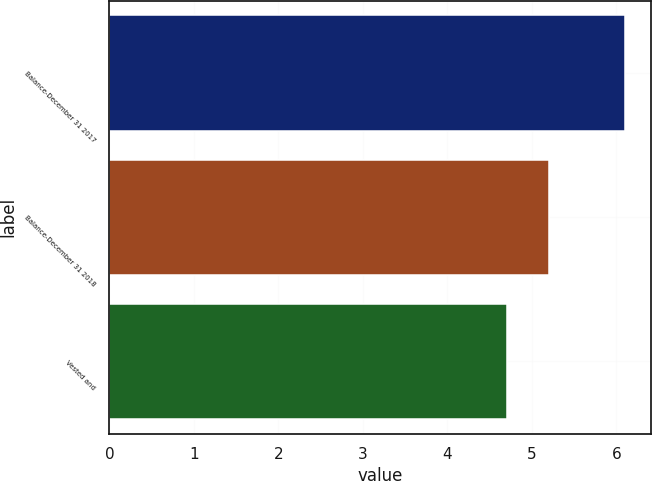<chart> <loc_0><loc_0><loc_500><loc_500><bar_chart><fcel>Balance-December 31 2017<fcel>Balance-December 31 2018<fcel>Vested and<nl><fcel>6.1<fcel>5.2<fcel>4.7<nl></chart> 